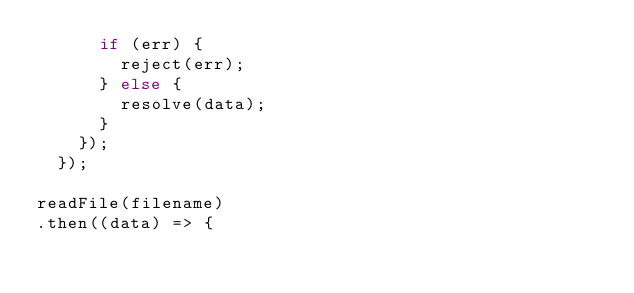Convert code to text. <code><loc_0><loc_0><loc_500><loc_500><_JavaScript_>      if (err) {
        reject(err);
      } else {
        resolve(data);
      }
    });
  });

readFile(filename)
.then((data) => {</code> 